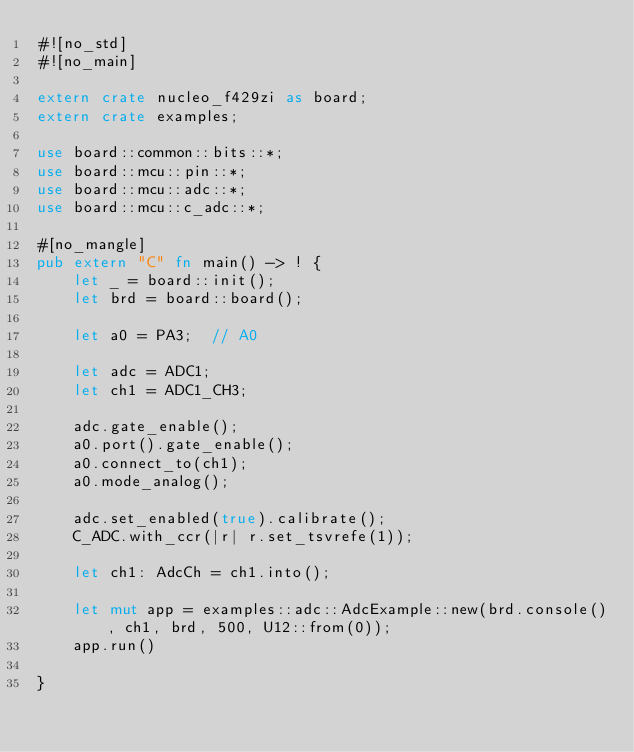<code> <loc_0><loc_0><loc_500><loc_500><_Rust_>#![no_std]
#![no_main]

extern crate nucleo_f429zi as board;
extern crate examples;

use board::common::bits::*;
use board::mcu::pin::*;
use board::mcu::adc::*;
use board::mcu::c_adc::*;

#[no_mangle]
pub extern "C" fn main() -> ! {
    let _ = board::init();
    let brd = board::board();
    
    let a0 = PA3;  // A0

    let adc = ADC1;
    let ch1 = ADC1_CH3;

    adc.gate_enable();
    a0.port().gate_enable();
    a0.connect_to(ch1);
    a0.mode_analog();

    adc.set_enabled(true).calibrate();
    C_ADC.with_ccr(|r| r.set_tsvrefe(1));    
    
    let ch1: AdcCh = ch1.into();

    let mut app = examples::adc::AdcExample::new(brd.console(), ch1, brd, 500, U12::from(0));
    app.run()

}
</code> 